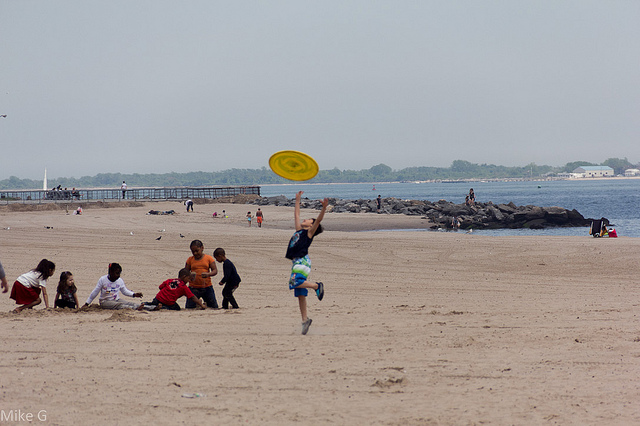Please extract the text content from this image. G Mike 